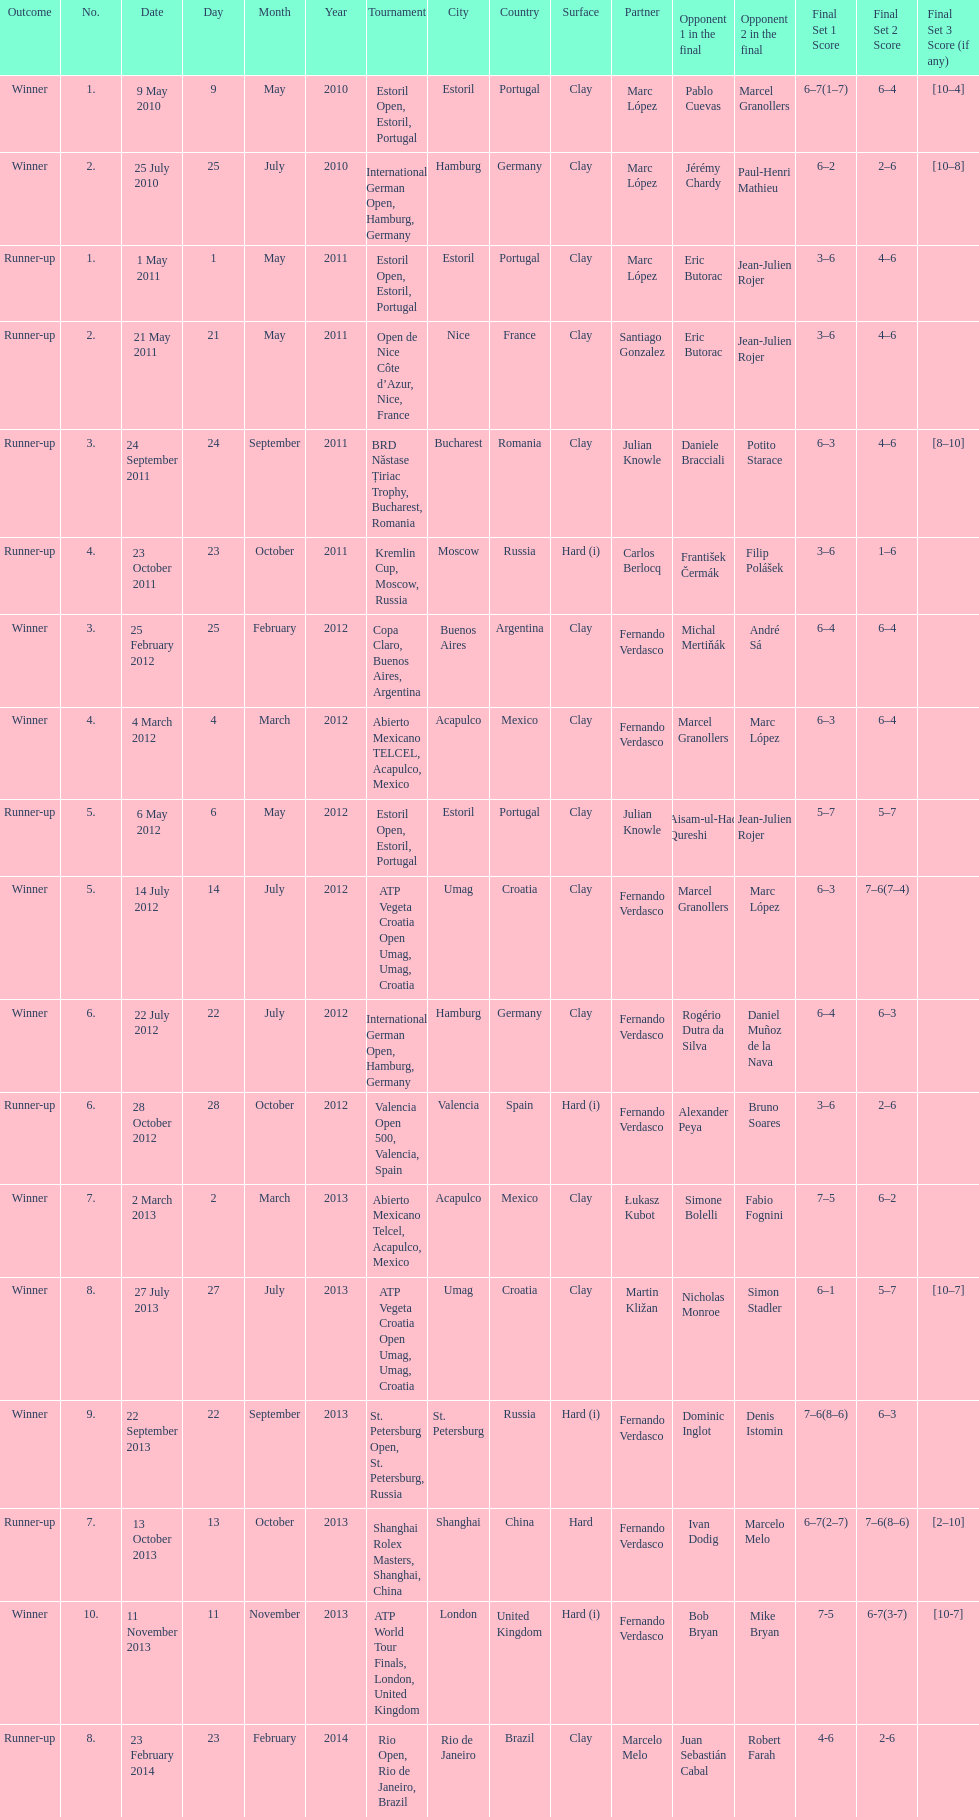Could you parse the entire table? {'header': ['Outcome', 'No.', 'Date', 'Day', 'Month', 'Year', 'Tournament', 'City', 'Country', 'Surface', 'Partner', 'Opponent 1 in the final', 'Opponent 2 in the final', 'Final Set 1 Score', 'Final Set 2 Score', 'Final Set 3 Score (if any)'], 'rows': [['Winner', '1.', '9 May 2010', '9', 'May', '2010', 'Estoril Open, Estoril, Portugal', 'Estoril', 'Portugal', 'Clay', 'Marc López', 'Pablo Cuevas', 'Marcel Granollers', '6–7(1–7)', '6–4', '[10–4]'], ['Winner', '2.', '25 July 2010', '25', 'July', '2010', 'International German Open, Hamburg, Germany', 'Hamburg', 'Germany', 'Clay', 'Marc López', 'Jérémy Chardy', 'Paul-Henri Mathieu', '6–2', '2–6', '[10–8]'], ['Runner-up', '1.', '1 May 2011', '1', 'May', '2011', 'Estoril Open, Estoril, Portugal', 'Estoril', 'Portugal', 'Clay', 'Marc López', 'Eric Butorac', 'Jean-Julien Rojer', '3–6', '4–6', ''], ['Runner-up', '2.', '21 May 2011', '21', 'May', '2011', 'Open de Nice Côte d’Azur, Nice, France', 'Nice', 'France', 'Clay', 'Santiago Gonzalez', 'Eric Butorac', 'Jean-Julien Rojer', '3–6', '4–6', ''], ['Runner-up', '3.', '24 September 2011', '24', 'September', '2011', 'BRD Năstase Țiriac Trophy, Bucharest, Romania', 'Bucharest', 'Romania', 'Clay', 'Julian Knowle', 'Daniele Bracciali', 'Potito Starace', '6–3', '4–6', '[8–10]'], ['Runner-up', '4.', '23 October 2011', '23', 'October', '2011', 'Kremlin Cup, Moscow, Russia', 'Moscow', 'Russia', 'Hard (i)', 'Carlos Berlocq', 'František Čermák', 'Filip Polášek', '3–6', '1–6', ''], ['Winner', '3.', '25 February 2012', '25', 'February', '2012', 'Copa Claro, Buenos Aires, Argentina', 'Buenos Aires', 'Argentina', 'Clay', 'Fernando Verdasco', 'Michal Mertiňák', 'André Sá', '6–4', '6–4', ''], ['Winner', '4.', '4 March 2012', '4', 'March', '2012', 'Abierto Mexicano TELCEL, Acapulco, Mexico', 'Acapulco', 'Mexico', 'Clay', 'Fernando Verdasco', 'Marcel Granollers', 'Marc López', '6–3', '6–4', ''], ['Runner-up', '5.', '6 May 2012', '6', 'May', '2012', 'Estoril Open, Estoril, Portugal', 'Estoril', 'Portugal', 'Clay', 'Julian Knowle', 'Aisam-ul-Haq Qureshi', 'Jean-Julien Rojer', '5–7', '5–7', ''], ['Winner', '5.', '14 July 2012', '14', 'July', '2012', 'ATP Vegeta Croatia Open Umag, Umag, Croatia', 'Umag', 'Croatia', 'Clay', 'Fernando Verdasco', 'Marcel Granollers', 'Marc López', '6–3', '7–6(7–4)', ''], ['Winner', '6.', '22 July 2012', '22', 'July', '2012', 'International German Open, Hamburg, Germany', 'Hamburg', 'Germany', 'Clay', 'Fernando Verdasco', 'Rogério Dutra da Silva', 'Daniel Muñoz de la Nava', '6–4', '6–3', ''], ['Runner-up', '6.', '28 October 2012', '28', 'October', '2012', 'Valencia Open 500, Valencia, Spain', 'Valencia', 'Spain', 'Hard (i)', 'Fernando Verdasco', 'Alexander Peya', 'Bruno Soares', '3–6', '2–6', ''], ['Winner', '7.', '2 March 2013', '2', 'March', '2013', 'Abierto Mexicano Telcel, Acapulco, Mexico', 'Acapulco', 'Mexico', 'Clay', 'Łukasz Kubot', 'Simone Bolelli', 'Fabio Fognini', '7–5', '6–2', ''], ['Winner', '8.', '27 July 2013', '27', 'July', '2013', 'ATP Vegeta Croatia Open Umag, Umag, Croatia', 'Umag', 'Croatia', 'Clay', 'Martin Kližan', 'Nicholas Monroe', 'Simon Stadler', '6–1', '5–7', '[10–7]'], ['Winner', '9.', '22 September 2013', '22', 'September', '2013', 'St. Petersburg Open, St. Petersburg, Russia', 'St. Petersburg', 'Russia', 'Hard (i)', 'Fernando Verdasco', 'Dominic Inglot', 'Denis Istomin', '7–6(8–6)', '6–3', ''], ['Runner-up', '7.', '13 October 2013', '13', 'October', '2013', 'Shanghai Rolex Masters, Shanghai, China', 'Shanghai', 'China', 'Hard', 'Fernando Verdasco', 'Ivan Dodig', 'Marcelo Melo', '6–7(2–7)', '7–6(8–6)', '[2–10]'], ['Winner', '10.', '11 November 2013', '11', 'November', '2013', 'ATP World Tour Finals, London, United Kingdom', 'London', 'United Kingdom', 'Hard (i)', 'Fernando Verdasco', 'Bob Bryan', 'Mike Bryan', '7-5', '6-7(3-7)', '[10-7]'], ['Runner-up', '8.', '23 February 2014', '23', 'February', '2014', 'Rio Open, Rio de Janeiro, Brazil', 'Rio de Janeiro', 'Brazil', 'Clay', 'Marcelo Melo', 'Juan Sebastián Cabal', 'Robert Farah', '4-6', '2-6', '']]} What is the total number of runner-ups listed on the chart? 8. 